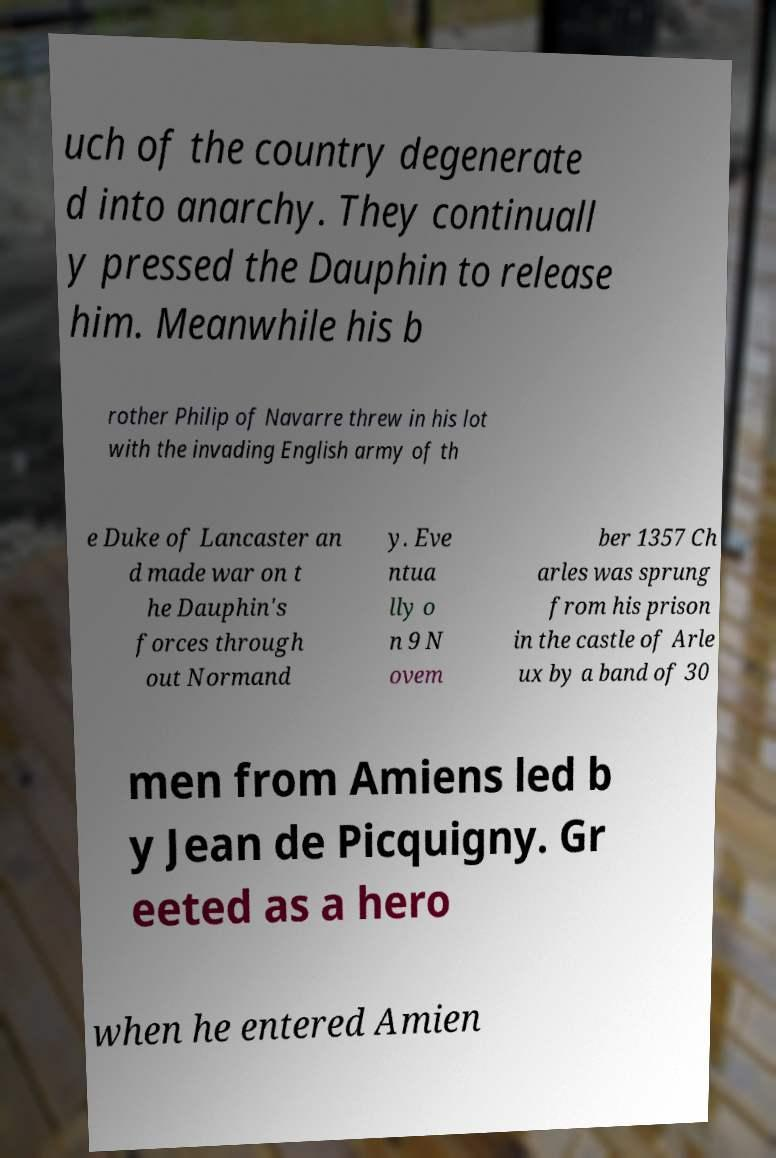For documentation purposes, I need the text within this image transcribed. Could you provide that? uch of the country degenerate d into anarchy. They continuall y pressed the Dauphin to release him. Meanwhile his b rother Philip of Navarre threw in his lot with the invading English army of th e Duke of Lancaster an d made war on t he Dauphin's forces through out Normand y. Eve ntua lly o n 9 N ovem ber 1357 Ch arles was sprung from his prison in the castle of Arle ux by a band of 30 men from Amiens led b y Jean de Picquigny. Gr eeted as a hero when he entered Amien 